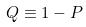Convert formula to latex. <formula><loc_0><loc_0><loc_500><loc_500>Q \equiv 1 - P</formula> 